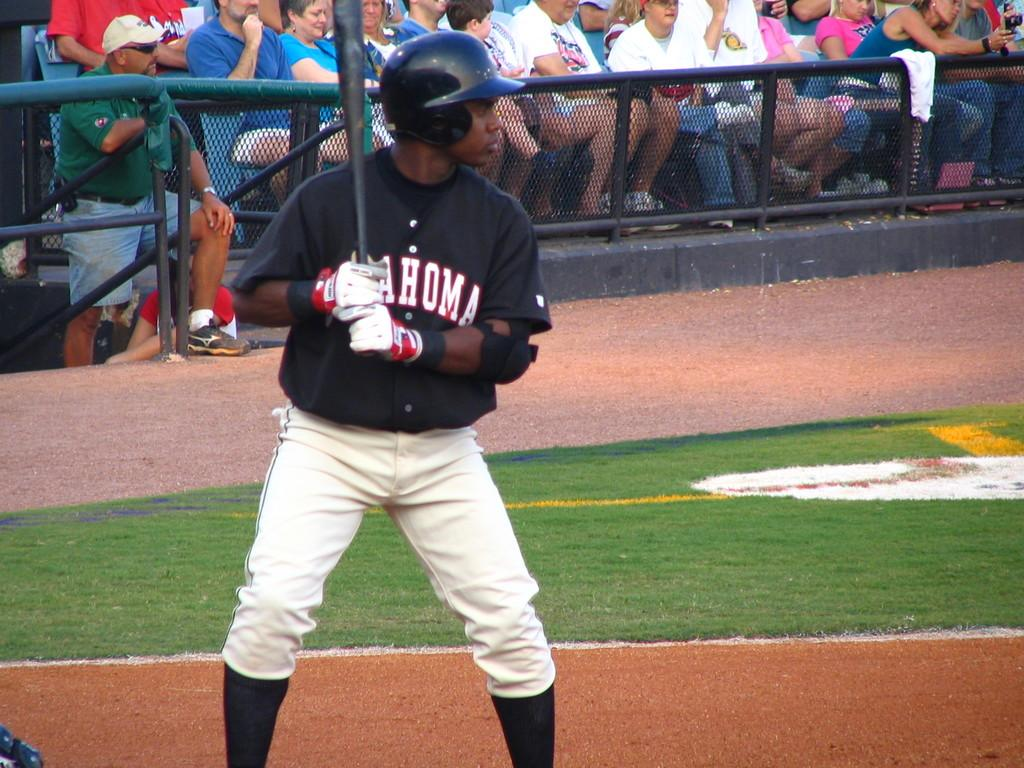<image>
Present a compact description of the photo's key features. Baseball player at bat with a black jersey that has oklahoma in white letters. 